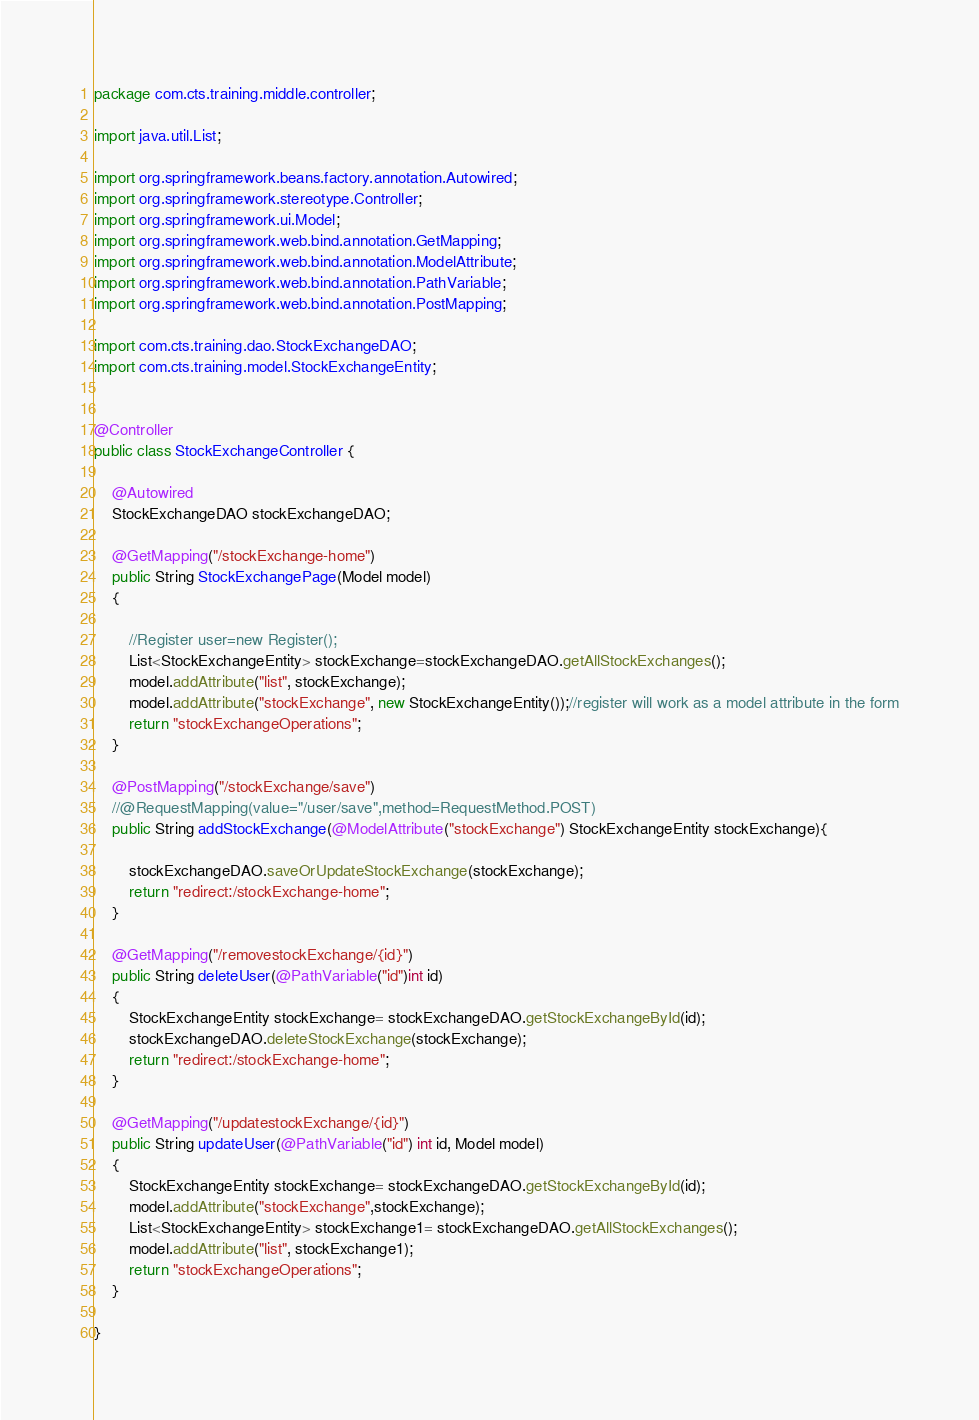Convert code to text. <code><loc_0><loc_0><loc_500><loc_500><_Java_>package com.cts.training.middle.controller;

import java.util.List;

import org.springframework.beans.factory.annotation.Autowired;
import org.springframework.stereotype.Controller;
import org.springframework.ui.Model;
import org.springframework.web.bind.annotation.GetMapping;
import org.springframework.web.bind.annotation.ModelAttribute;
import org.springframework.web.bind.annotation.PathVariable;
import org.springframework.web.bind.annotation.PostMapping;

import com.cts.training.dao.StockExchangeDAO;
import com.cts.training.model.StockExchangeEntity;


@Controller
public class StockExchangeController {
	
	@Autowired
	StockExchangeDAO stockExchangeDAO;
	
	@GetMapping("/stockExchange-home")
	public String StockExchangePage(Model model)
	{
		
		//Register user=new Register();
		List<StockExchangeEntity> stockExchange=stockExchangeDAO.getAllStockExchanges();
		model.addAttribute("list", stockExchange);
		model.addAttribute("stockExchange", new StockExchangeEntity());//register will work as a model attribute in the form
		return "stockExchangeOperations";
	}
	
	@PostMapping("/stockExchange/save")
	//@RequestMapping(value="/user/save",method=RequestMethod.POST)
	public String addStockExchange(@ModelAttribute("stockExchange") StockExchangeEntity stockExchange){
		
		stockExchangeDAO.saveOrUpdateStockExchange(stockExchange);
		return "redirect:/stockExchange-home";
	}
	
	@GetMapping("/removestockExchange/{id}")
	public String deleteUser(@PathVariable("id")int id)
	{
		StockExchangeEntity stockExchange= stockExchangeDAO.getStockExchangeById(id);
		stockExchangeDAO.deleteStockExchange(stockExchange);
		return "redirect:/stockExchange-home";
	}
	
	@GetMapping("/updatestockExchange/{id}")
	public String updateUser(@PathVariable("id") int id, Model model)
	{
		StockExchangeEntity stockExchange= stockExchangeDAO.getStockExchangeById(id);
		model.addAttribute("stockExchange",stockExchange);
		List<StockExchangeEntity> stockExchange1= stockExchangeDAO.getAllStockExchanges();
		model.addAttribute("list", stockExchange1);
		return "stockExchangeOperations";
	}

}
</code> 